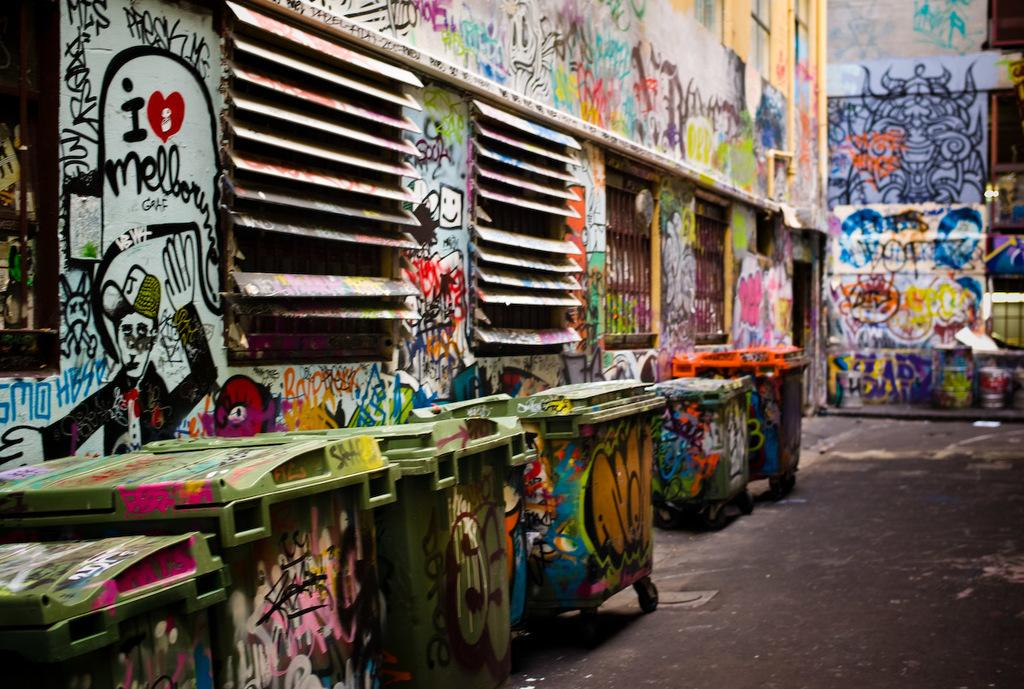<image>
Summarize the visual content of the image. An alleyway's walls are covered in graffiti, one reading " I love Melbourne" 